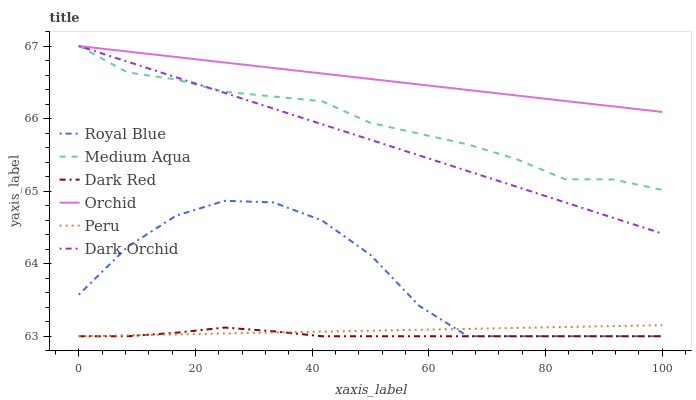Does Dark Red have the minimum area under the curve?
Answer yes or no. Yes. Does Orchid have the maximum area under the curve?
Answer yes or no. Yes. Does Dark Orchid have the minimum area under the curve?
Answer yes or no. No. Does Dark Orchid have the maximum area under the curve?
Answer yes or no. No. Is Peru the smoothest?
Answer yes or no. Yes. Is Royal Blue the roughest?
Answer yes or no. Yes. Is Dark Orchid the smoothest?
Answer yes or no. No. Is Dark Orchid the roughest?
Answer yes or no. No. Does Dark Red have the lowest value?
Answer yes or no. Yes. Does Dark Orchid have the lowest value?
Answer yes or no. No. Does Orchid have the highest value?
Answer yes or no. Yes. Does Royal Blue have the highest value?
Answer yes or no. No. Is Dark Red less than Dark Orchid?
Answer yes or no. Yes. Is Medium Aqua greater than Dark Red?
Answer yes or no. Yes. Does Royal Blue intersect Peru?
Answer yes or no. Yes. Is Royal Blue less than Peru?
Answer yes or no. No. Is Royal Blue greater than Peru?
Answer yes or no. No. Does Dark Red intersect Dark Orchid?
Answer yes or no. No. 